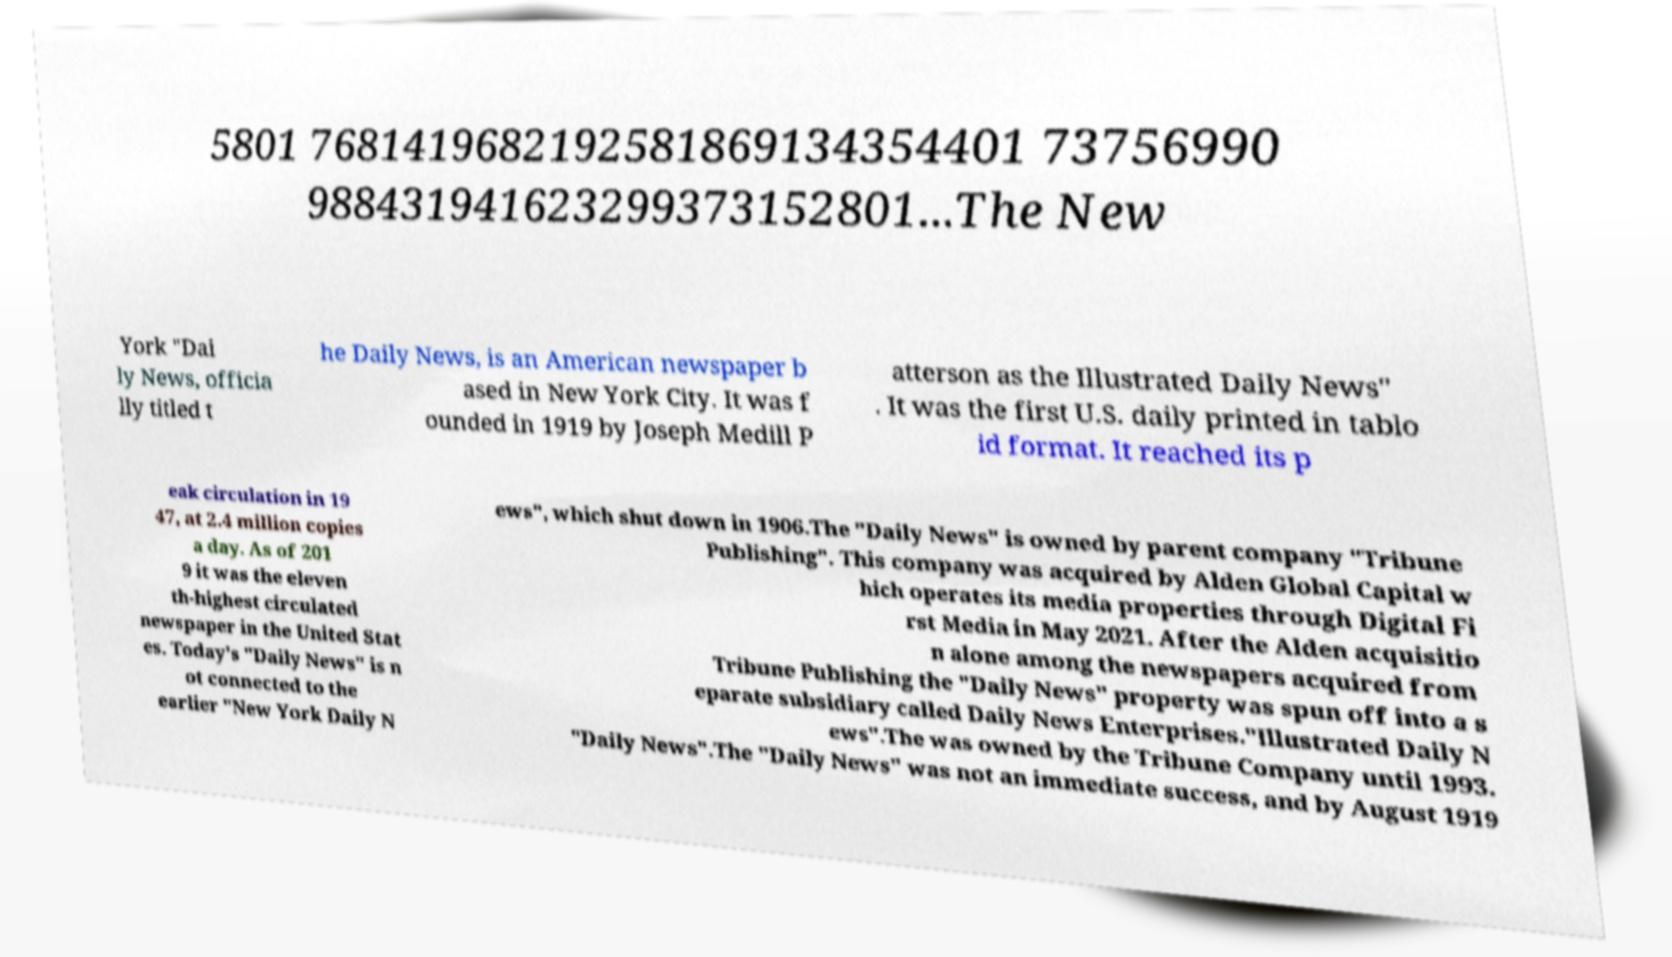Please read and relay the text visible in this image. What does it say? 5801 7681419682192581869134354401 73756990 988431941623299373152801...The New York "Dai ly News, officia lly titled t he Daily News, is an American newspaper b ased in New York City. It was f ounded in 1919 by Joseph Medill P atterson as the Illustrated Daily News" . It was the first U.S. daily printed in tablo id format. It reached its p eak circulation in 19 47, at 2.4 million copies a day. As of 201 9 it was the eleven th-highest circulated newspaper in the United Stat es. Today's "Daily News" is n ot connected to the earlier "New York Daily N ews", which shut down in 1906.The "Daily News" is owned by parent company "Tribune Publishing". This company was acquired by Alden Global Capital w hich operates its media properties through Digital Fi rst Media in May 2021. After the Alden acquisitio n alone among the newspapers acquired from Tribune Publishing the "Daily News" property was spun off into a s eparate subsidiary called Daily News Enterprises."Illustrated Daily N ews".The was owned by the Tribune Company until 1993. "Daily News".The "Daily News" was not an immediate success, and by August 1919 